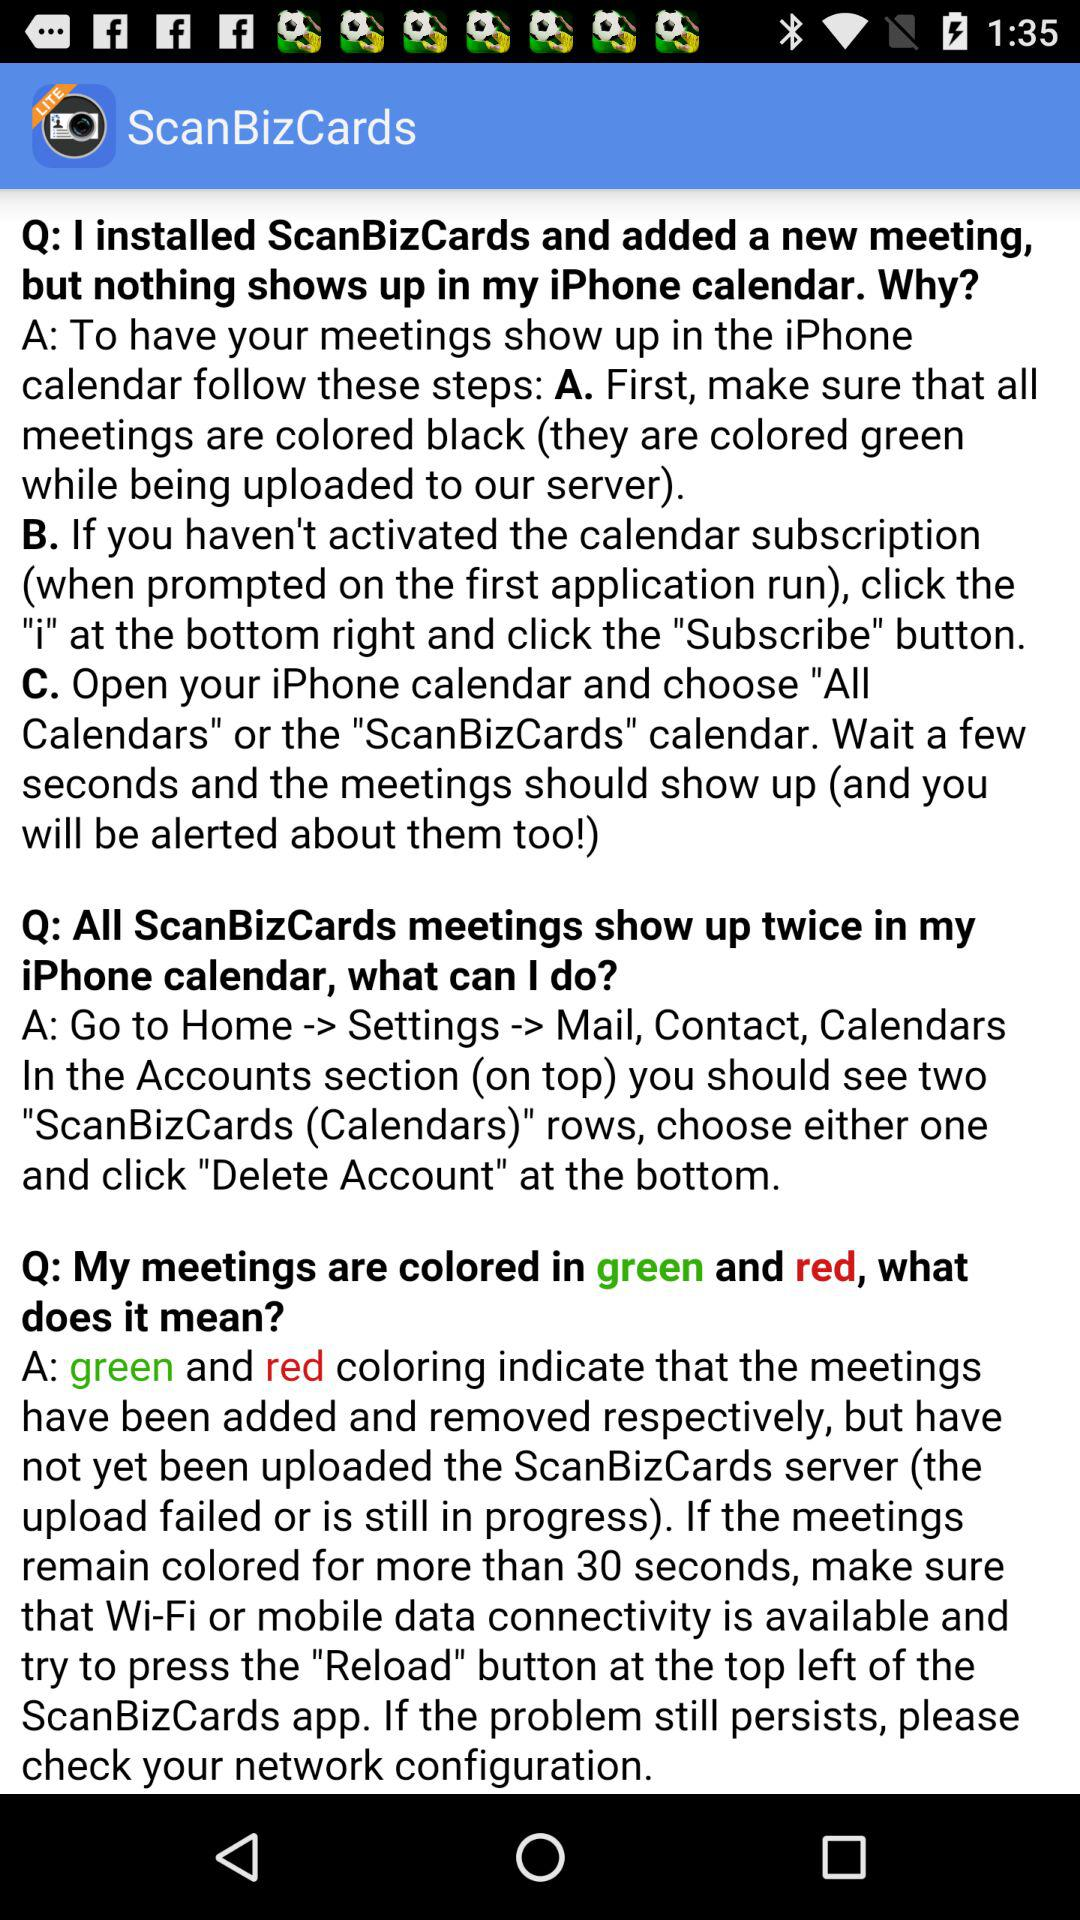What is the application name? The application name is "ScanBizCards". 